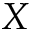<formula> <loc_0><loc_0><loc_500><loc_500>X</formula> 